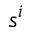<formula> <loc_0><loc_0><loc_500><loc_500>s ^ { i }</formula> 